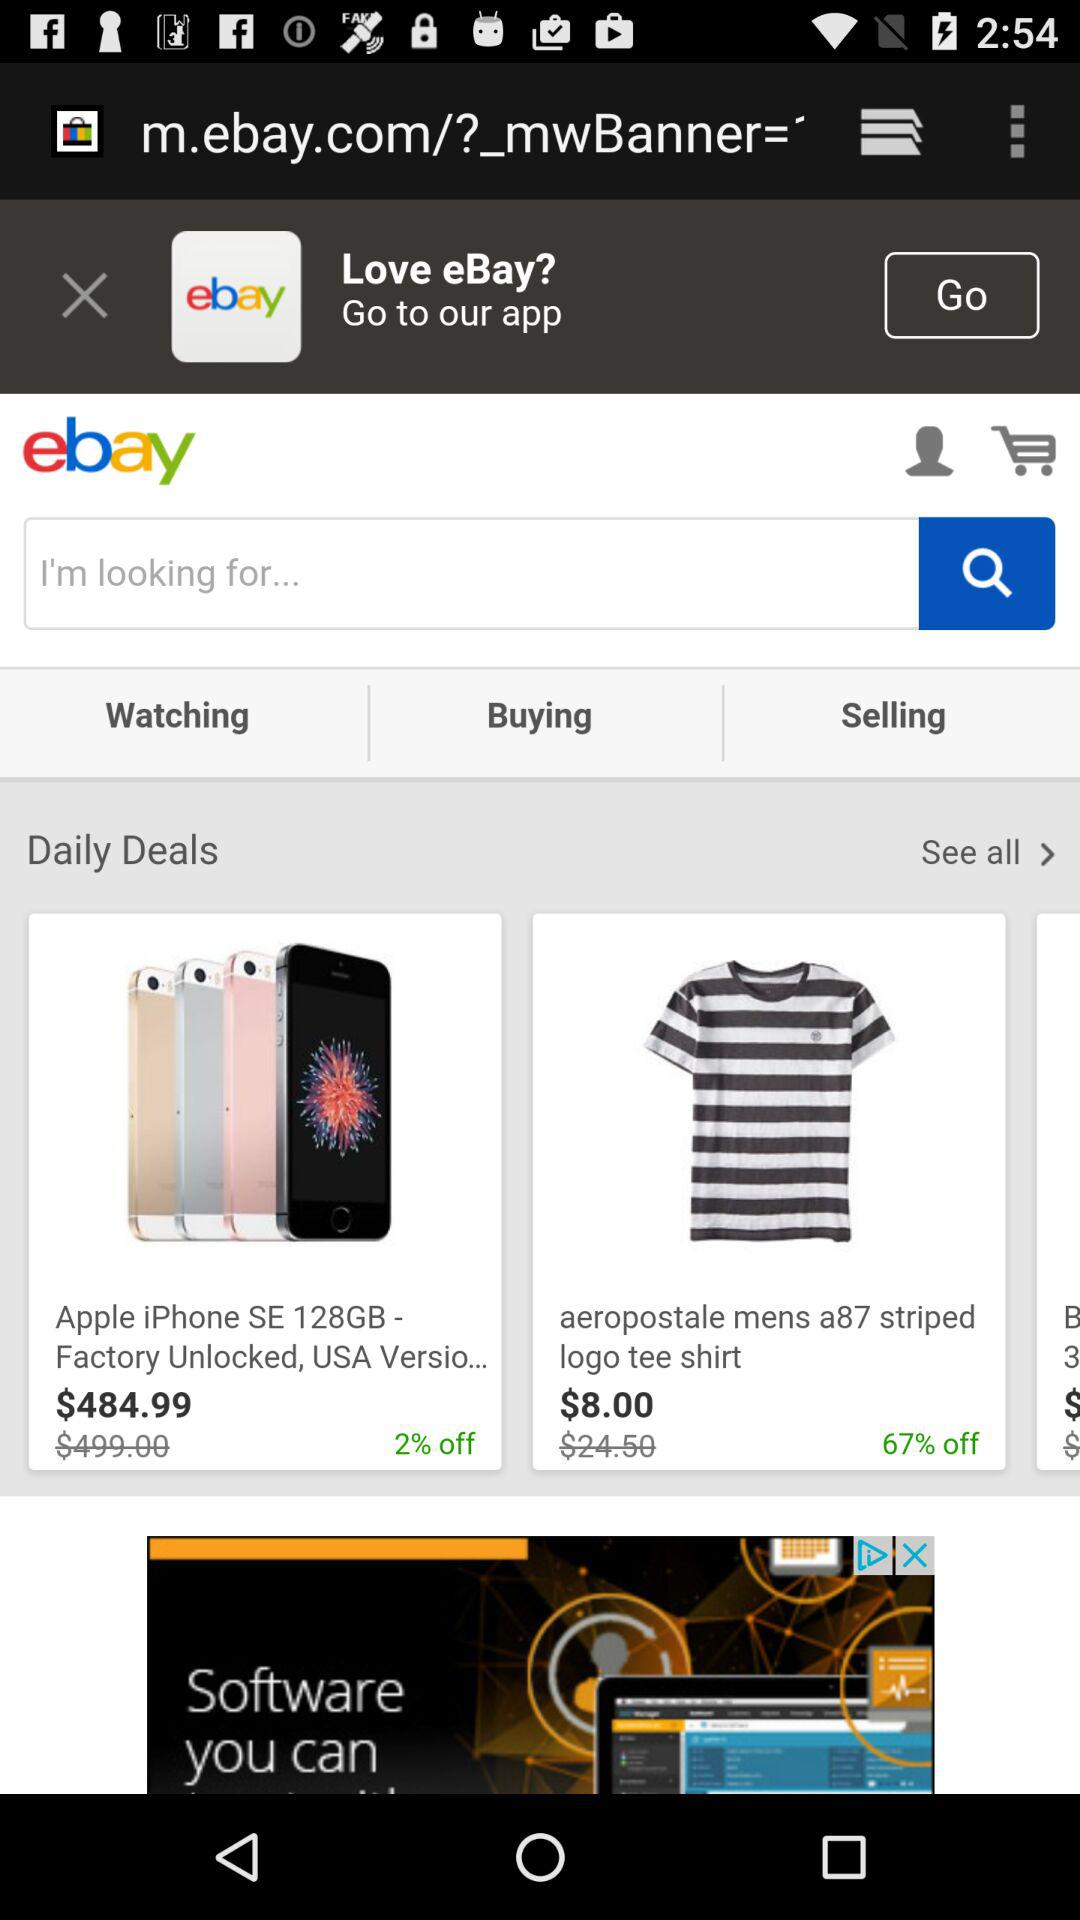How much of the discount is there on the "striped logo tee shirt"? The discount on the "striped logo tee shirt" is 67%. 